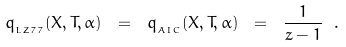Convert formula to latex. <formula><loc_0><loc_0><loc_500><loc_500>q _ { _ { L Z 7 7 } } ( X , T , \alpha ) \ = \ q _ { _ { A I C } } ( X , T , \alpha ) \ = \ \frac { 1 } { z - 1 } \ .</formula> 